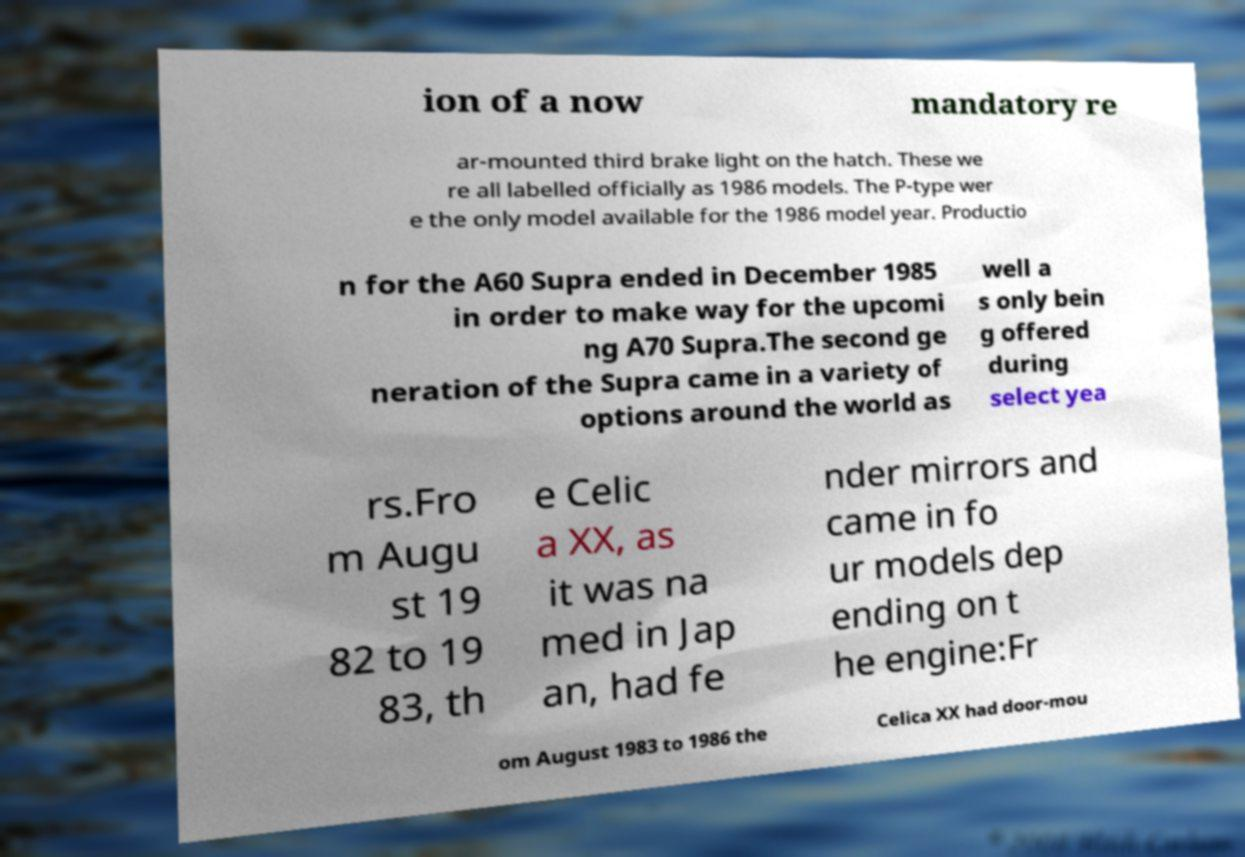I need the written content from this picture converted into text. Can you do that? ion of a now mandatory re ar-mounted third brake light on the hatch. These we re all labelled officially as 1986 models. The P-type wer e the only model available for the 1986 model year. Productio n for the A60 Supra ended in December 1985 in order to make way for the upcomi ng A70 Supra.The second ge neration of the Supra came in a variety of options around the world as well a s only bein g offered during select yea rs.Fro m Augu st 19 82 to 19 83, th e Celic a XX, as it was na med in Jap an, had fe nder mirrors and came in fo ur models dep ending on t he engine:Fr om August 1983 to 1986 the Celica XX had door-mou 